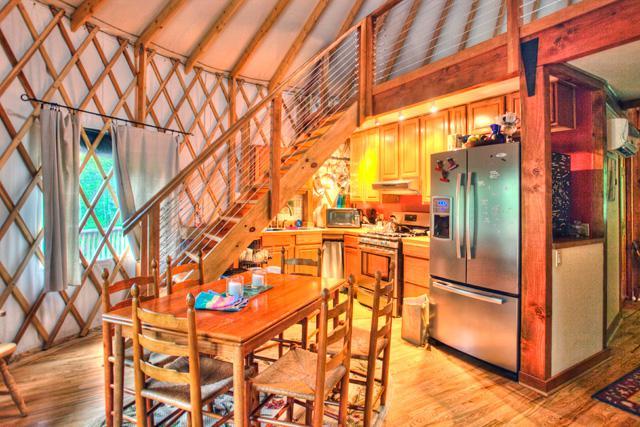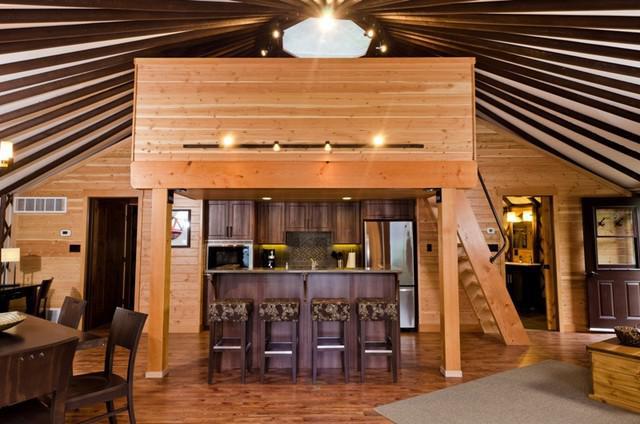The first image is the image on the left, the second image is the image on the right. Examine the images to the left and right. Is the description "There is exactly one ceiling fan in the image on the right." accurate? Answer yes or no. No. 